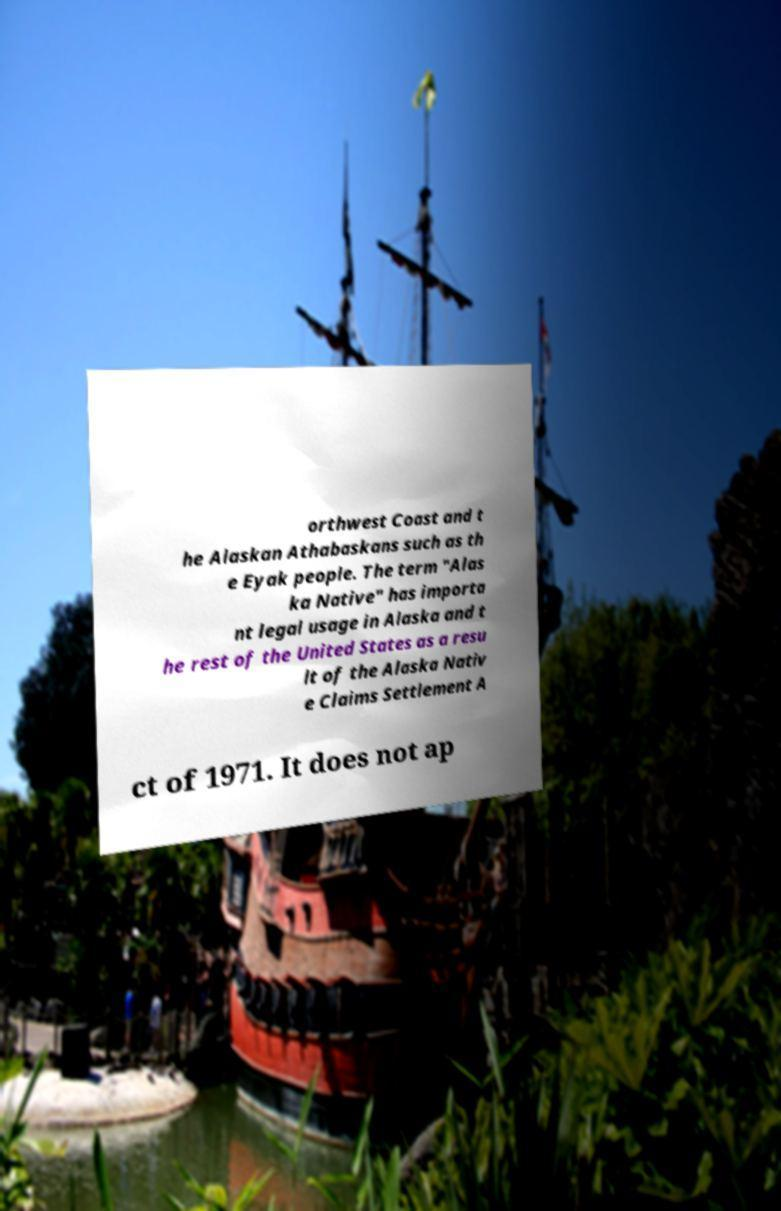Please identify and transcribe the text found in this image. orthwest Coast and t he Alaskan Athabaskans such as th e Eyak people. The term "Alas ka Native" has importa nt legal usage in Alaska and t he rest of the United States as a resu lt of the Alaska Nativ e Claims Settlement A ct of 1971. It does not ap 